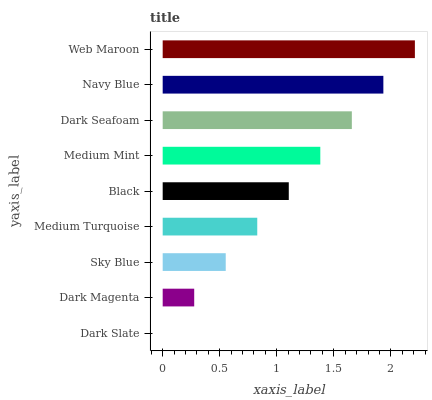Is Dark Slate the minimum?
Answer yes or no. Yes. Is Web Maroon the maximum?
Answer yes or no. Yes. Is Dark Magenta the minimum?
Answer yes or no. No. Is Dark Magenta the maximum?
Answer yes or no. No. Is Dark Magenta greater than Dark Slate?
Answer yes or no. Yes. Is Dark Slate less than Dark Magenta?
Answer yes or no. Yes. Is Dark Slate greater than Dark Magenta?
Answer yes or no. No. Is Dark Magenta less than Dark Slate?
Answer yes or no. No. Is Black the high median?
Answer yes or no. Yes. Is Black the low median?
Answer yes or no. Yes. Is Medium Turquoise the high median?
Answer yes or no. No. Is Medium Mint the low median?
Answer yes or no. No. 